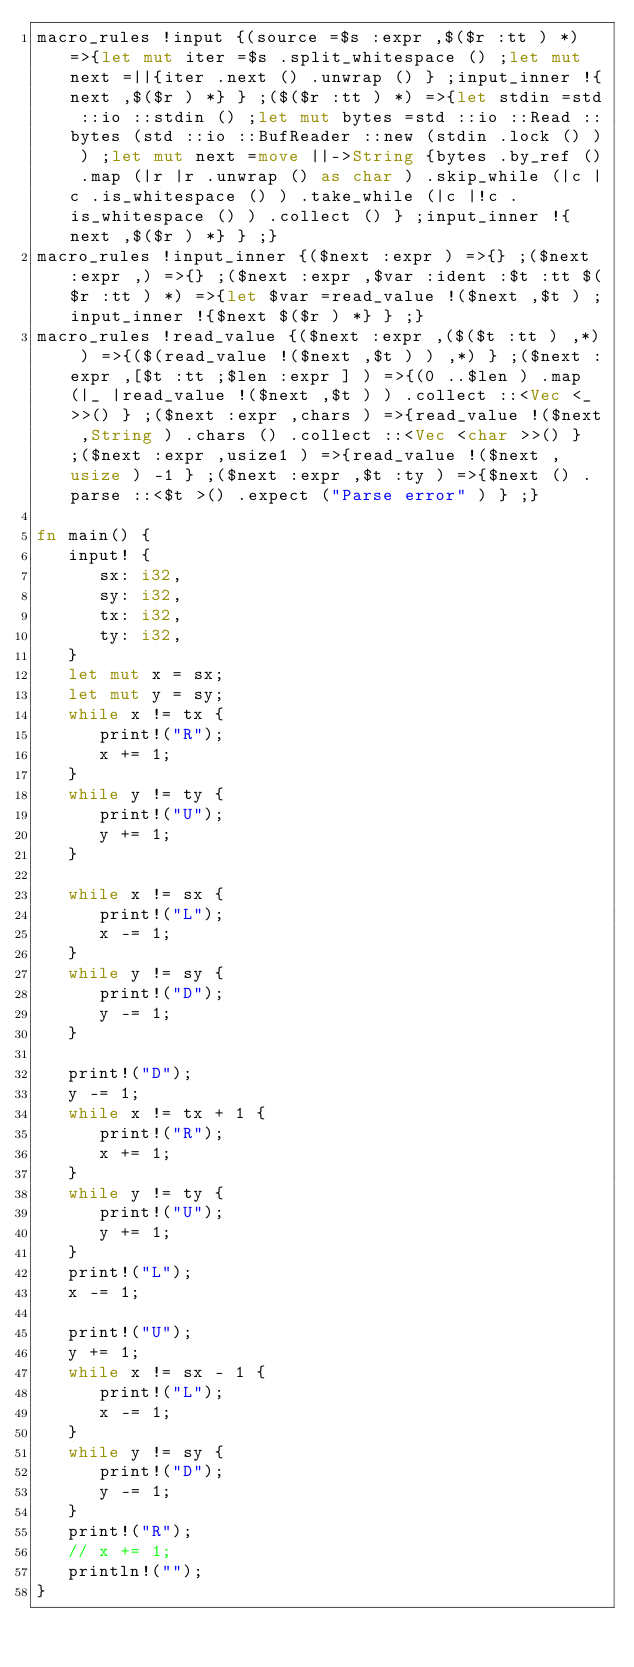Convert code to text. <code><loc_0><loc_0><loc_500><loc_500><_Rust_>macro_rules !input {(source =$s :expr ,$($r :tt ) *) =>{let mut iter =$s .split_whitespace () ;let mut next =||{iter .next () .unwrap () } ;input_inner !{next ,$($r ) *} } ;($($r :tt ) *) =>{let stdin =std ::io ::stdin () ;let mut bytes =std ::io ::Read ::bytes (std ::io ::BufReader ::new (stdin .lock () ) ) ;let mut next =move ||->String {bytes .by_ref () .map (|r |r .unwrap () as char ) .skip_while (|c |c .is_whitespace () ) .take_while (|c |!c .is_whitespace () ) .collect () } ;input_inner !{next ,$($r ) *} } ;}
macro_rules !input_inner {($next :expr ) =>{} ;($next :expr ,) =>{} ;($next :expr ,$var :ident :$t :tt $($r :tt ) *) =>{let $var =read_value !($next ,$t ) ;input_inner !{$next $($r ) *} } ;}
macro_rules !read_value {($next :expr ,($($t :tt ) ,*) ) =>{($(read_value !($next ,$t ) ) ,*) } ;($next :expr ,[$t :tt ;$len :expr ] ) =>{(0 ..$len ) .map (|_ |read_value !($next ,$t ) ) .collect ::<Vec <_ >>() } ;($next :expr ,chars ) =>{read_value !($next ,String ) .chars () .collect ::<Vec <char >>() } ;($next :expr ,usize1 ) =>{read_value !($next ,usize ) -1 } ;($next :expr ,$t :ty ) =>{$next () .parse ::<$t >() .expect ("Parse error" ) } ;}

fn main() {
   input! {
      sx: i32,
      sy: i32,
      tx: i32,
      ty: i32,
   }
   let mut x = sx;
   let mut y = sy;
   while x != tx {
      print!("R");
      x += 1;
   }
   while y != ty {
      print!("U");
      y += 1;
   }

   while x != sx {
      print!("L");
      x -= 1;
   }
   while y != sy {
      print!("D");
      y -= 1;
   }

   print!("D");
   y -= 1;
   while x != tx + 1 {
      print!("R");
      x += 1;
   }
   while y != ty {
      print!("U");
      y += 1;
   }
   print!("L");
   x -= 1;

   print!("U");
   y += 1;
   while x != sx - 1 {
      print!("L");
      x -= 1;
   }
   while y != sy {
      print!("D");
      y -= 1;
   }
   print!("R");
   // x += 1;
   println!("");
}
</code> 